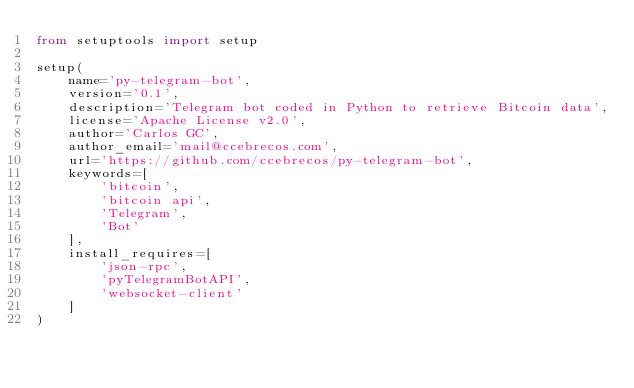<code> <loc_0><loc_0><loc_500><loc_500><_Python_>from setuptools import setup

setup(
    name='py-telegram-bot',
    version='0.1',
    description='Telegram bot coded in Python to retrieve Bitcoin data',
    license='Apache License v2.0',
    author='Carlos GC',
    author_email='mail@ccebrecos.com',
    url='https://github.com/ccebrecos/py-telegram-bot',
    keywords=[
        'bitcoin',
        'bitcoin api',
        'Telegram',
        'Bot'
    ],
    install_requires=[
        'json-rpc',
        'pyTelegramBotAPI',
        'websocket-client'
    ]
)
</code> 